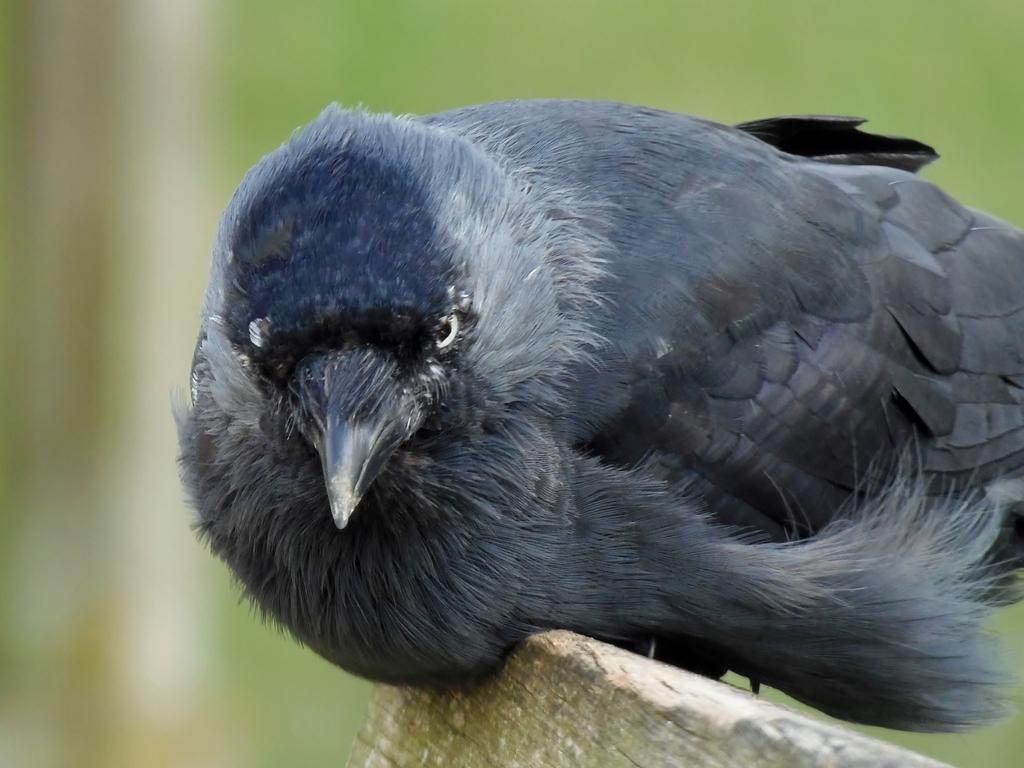What type of bird is in the image? There is a crow in the image. What surface is the crow on? The crow is on a wooden surface. Can you describe the background of the image? The background of the image is blurred. What type of quartz can be seen in the image? There is no quartz present in the image. What type of border is surrounding the crow in the image? There is no border surrounding the crow in the image. 